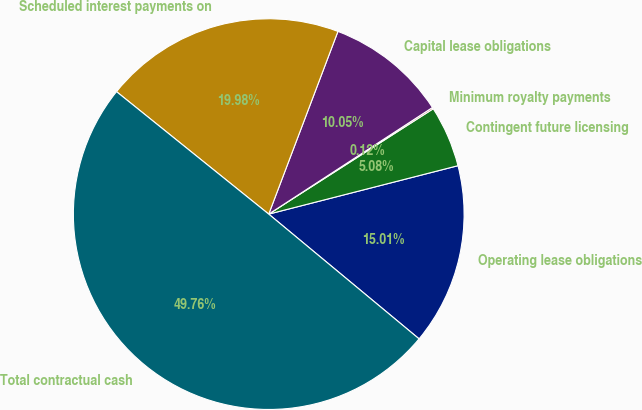Convert chart. <chart><loc_0><loc_0><loc_500><loc_500><pie_chart><fcel>Operating lease obligations<fcel>Contingent future licensing<fcel>Minimum royalty payments<fcel>Capital lease obligations<fcel>Scheduled interest payments on<fcel>Total contractual cash<nl><fcel>15.01%<fcel>5.08%<fcel>0.12%<fcel>10.05%<fcel>19.98%<fcel>49.76%<nl></chart> 